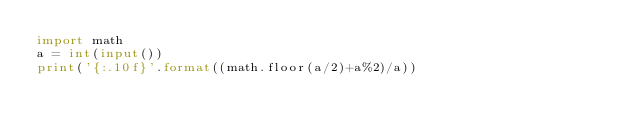Convert code to text. <code><loc_0><loc_0><loc_500><loc_500><_Python_>import math
a = int(input())
print('{:.10f}'.format((math.floor(a/2)+a%2)/a))</code> 